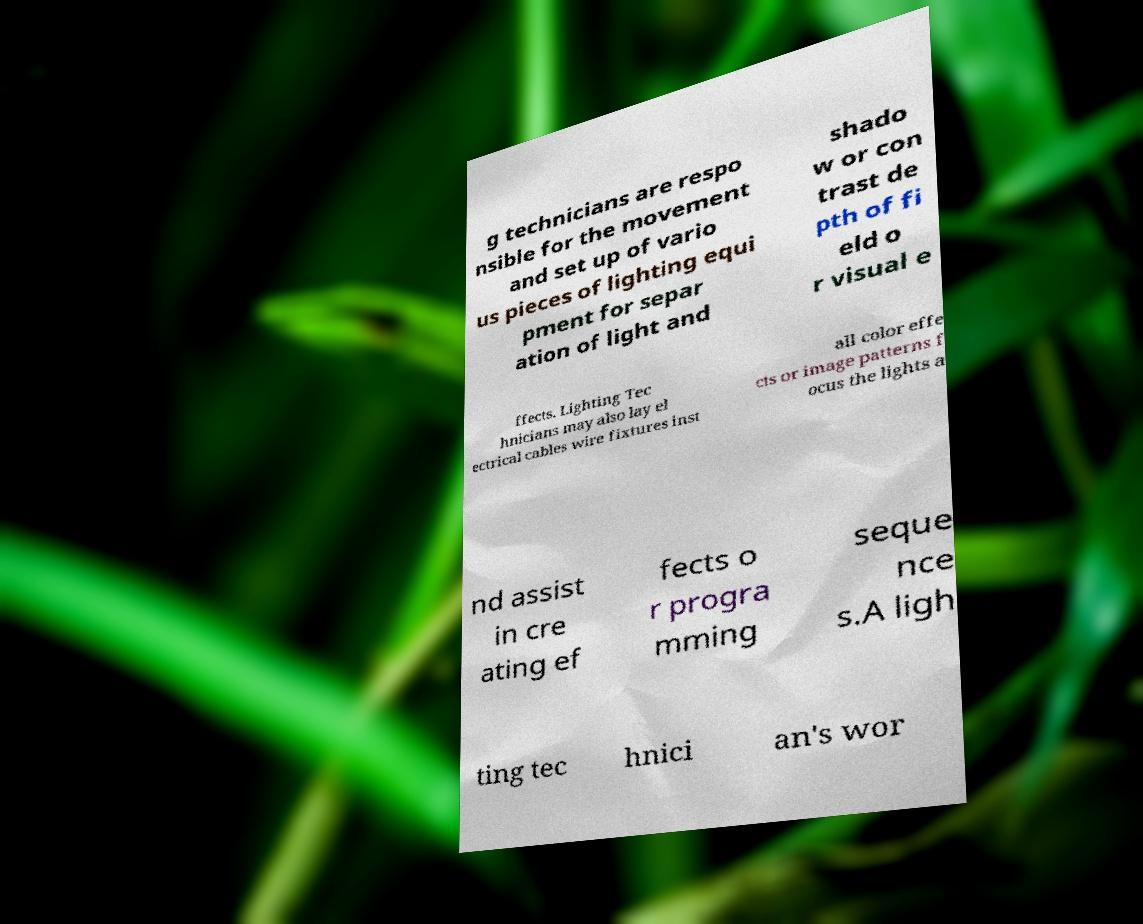Can you read and provide the text displayed in the image?This photo seems to have some interesting text. Can you extract and type it out for me? g technicians are respo nsible for the movement and set up of vario us pieces of lighting equi pment for separ ation of light and shado w or con trast de pth of fi eld o r visual e ffects. Lighting Tec hnicians may also lay el ectrical cables wire fixtures inst all color effe cts or image patterns f ocus the lights a nd assist in cre ating ef fects o r progra mming seque nce s.A ligh ting tec hnici an's wor 